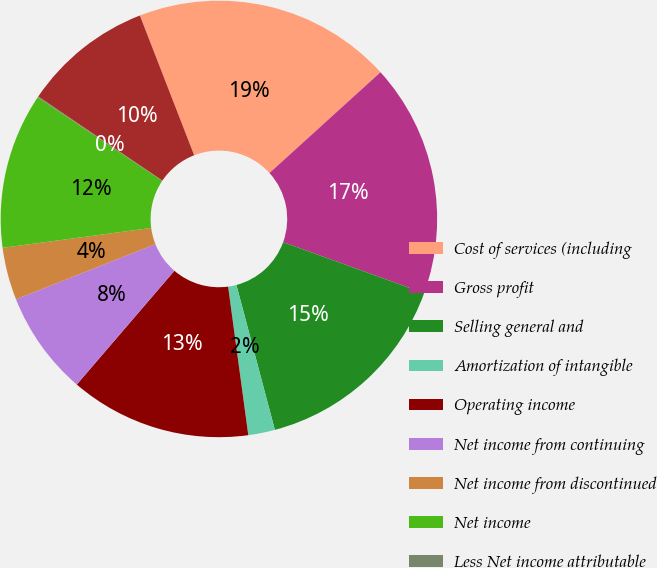<chart> <loc_0><loc_0><loc_500><loc_500><pie_chart><fcel>Cost of services (including<fcel>Gross profit<fcel>Selling general and<fcel>Amortization of intangible<fcel>Operating income<fcel>Net income from continuing<fcel>Net income from discontinued<fcel>Net income<fcel>Less Net income attributable<fcel>Net income attributable to<nl><fcel>19.17%<fcel>17.26%<fcel>15.35%<fcel>1.98%<fcel>13.44%<fcel>7.71%<fcel>3.89%<fcel>11.53%<fcel>0.07%<fcel>9.62%<nl></chart> 